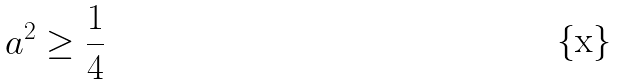<formula> <loc_0><loc_0><loc_500><loc_500>a ^ { 2 } \geq \frac { 1 } { 4 }</formula> 